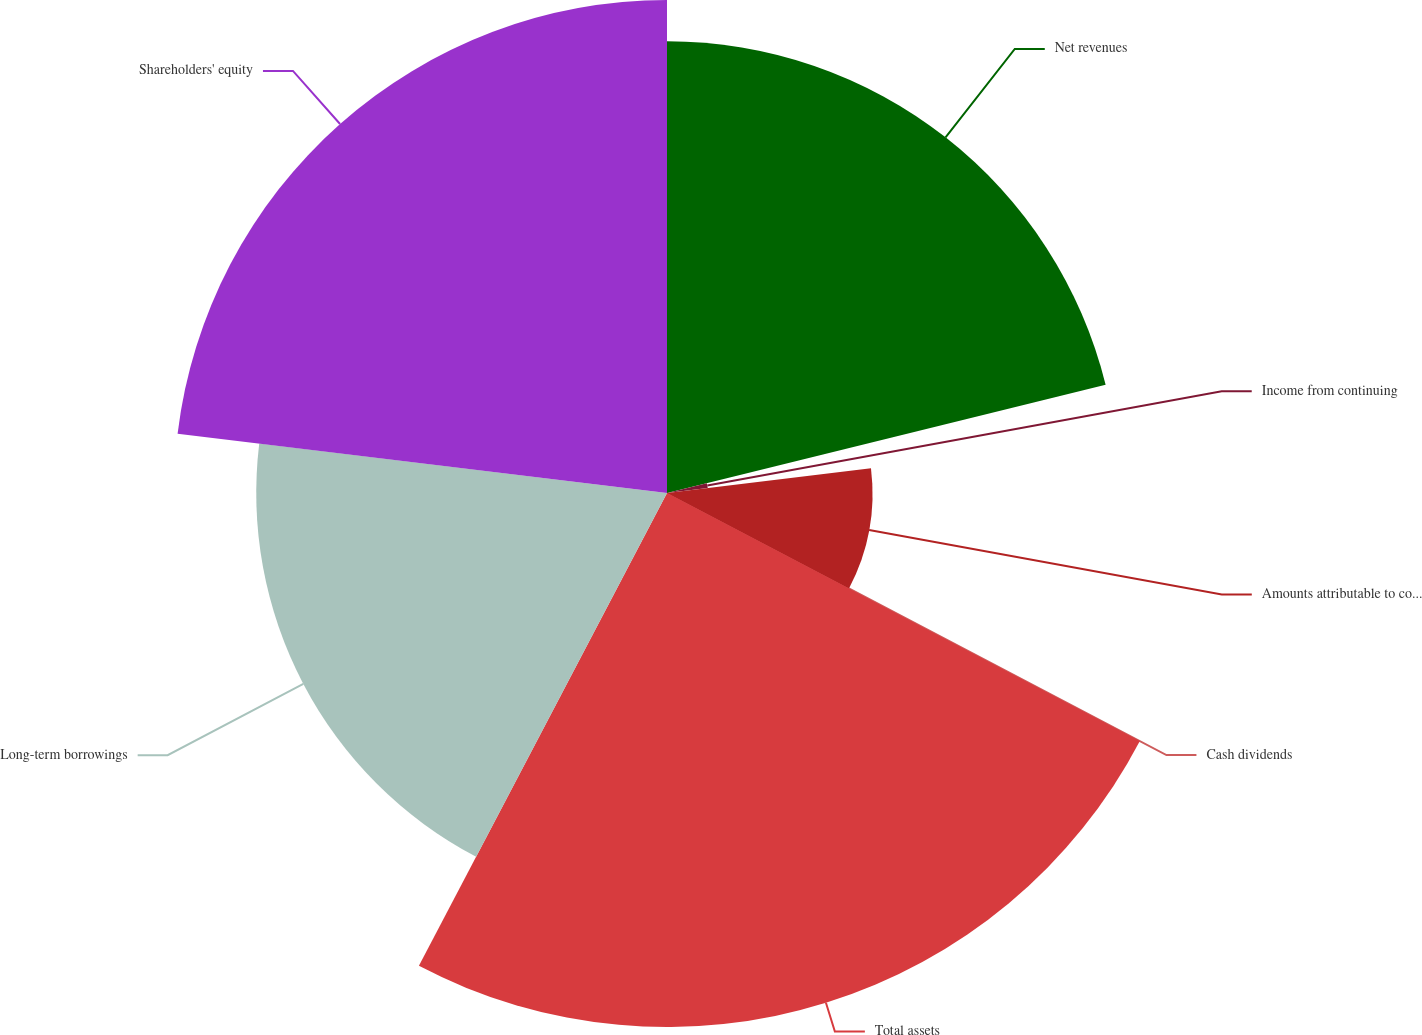Convert chart. <chart><loc_0><loc_0><loc_500><loc_500><pie_chart><fcel>Net revenues<fcel>Income from continuing<fcel>Amounts attributable to common<fcel>Cash dividends<fcel>Total assets<fcel>Long-term borrowings<fcel>Shareholders' equity<nl><fcel>21.15%<fcel>1.92%<fcel>9.62%<fcel>0.0%<fcel>25.0%<fcel>19.23%<fcel>23.08%<nl></chart> 